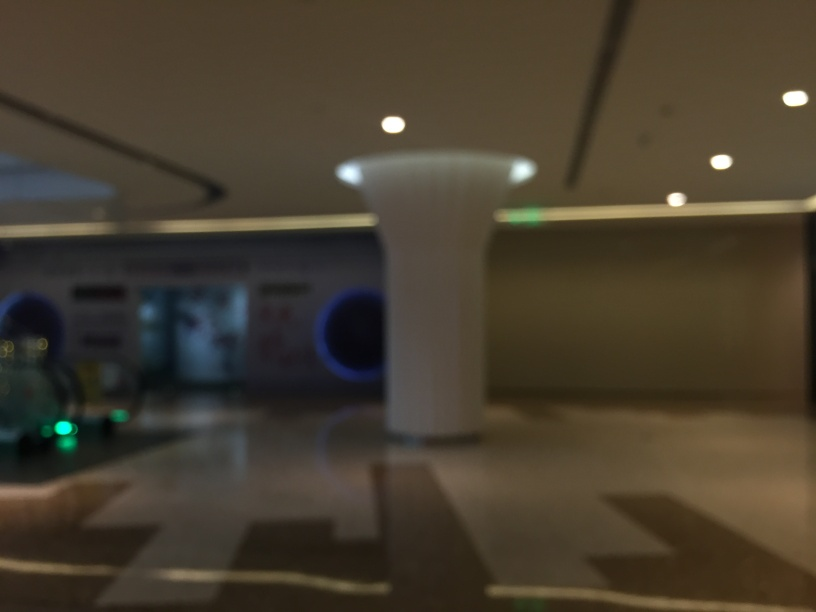What kind of emotions does this setting invoke? The blurred perspective of this setting may evoke a feeling of confusion or disorientation, perhaps resembling how one might feel if rushing through an unfamiliar space or experiencing a moment of uncertainty. 